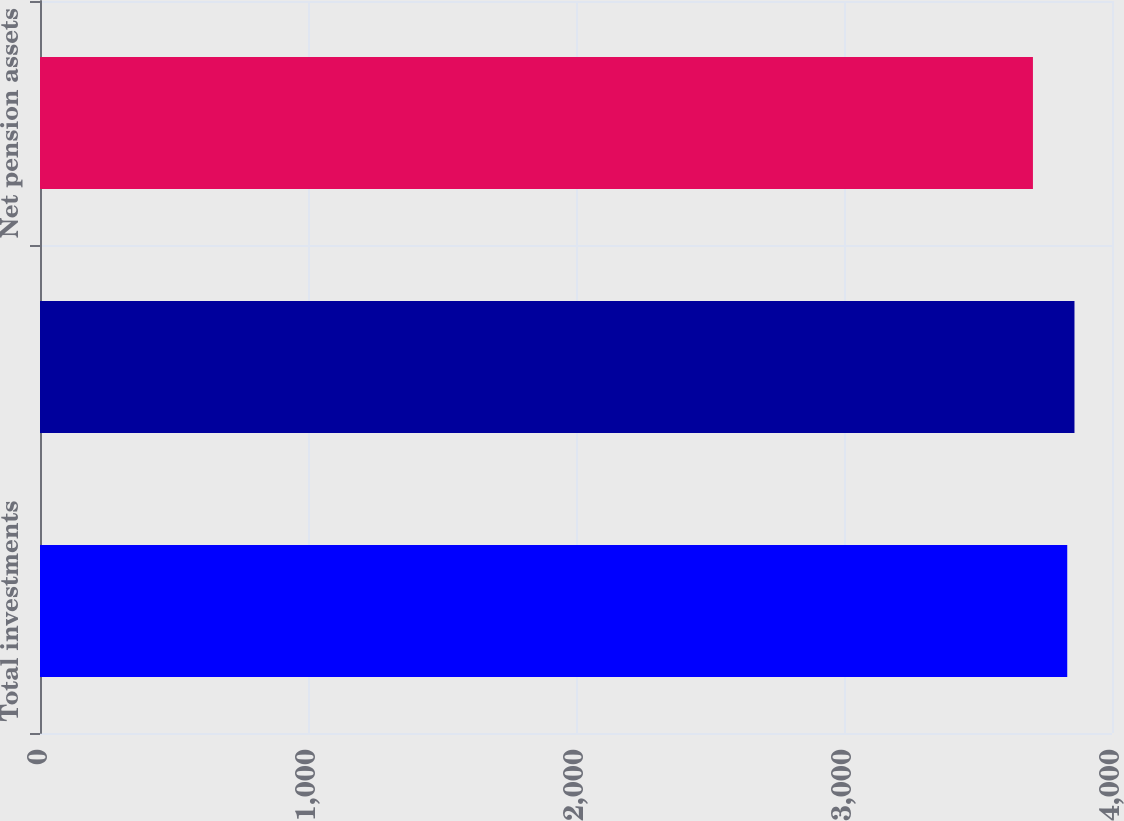Convert chart. <chart><loc_0><loc_0><loc_500><loc_500><bar_chart><fcel>Total investments<fcel>Total assets<fcel>Net pension assets<nl><fcel>3833<fcel>3860<fcel>3705<nl></chart> 